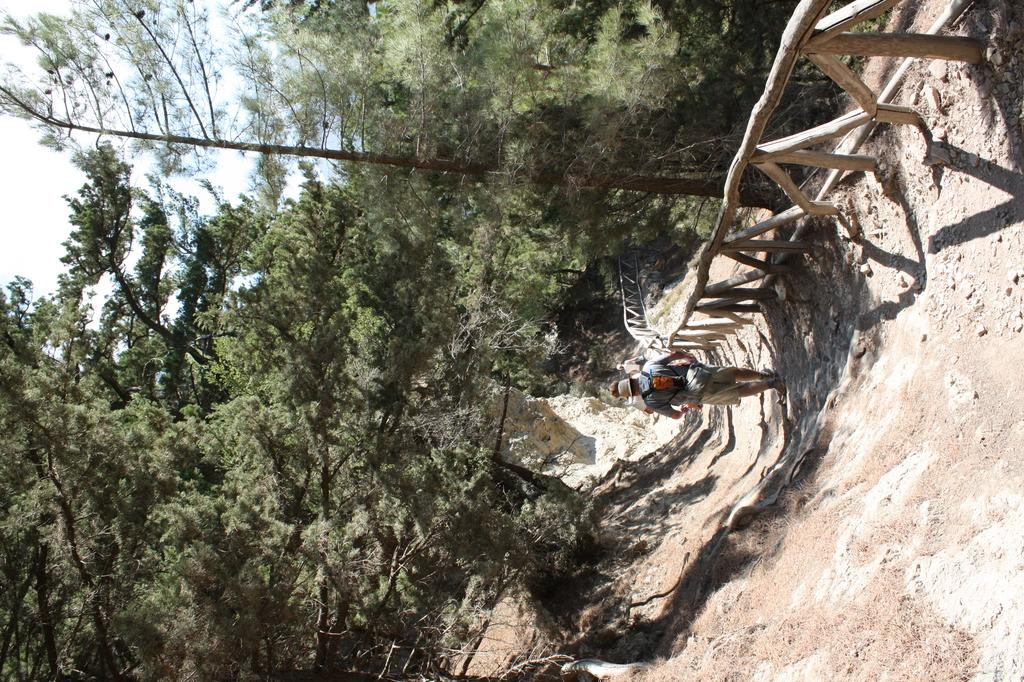How many people are in the image? There are two people in the image. Where are the people located in the image? The people are on a path. What is on the right side of the people? There is a wooden fence on the right side of the people. What type of vegetation can be seen in the image? There are trees in the image. What is visible behind the trees? The sky is visible behind the trees. What type of screw is holding the badge on the wooden fence in the image? There is no screw or badge present on the wooden fence in the image. 